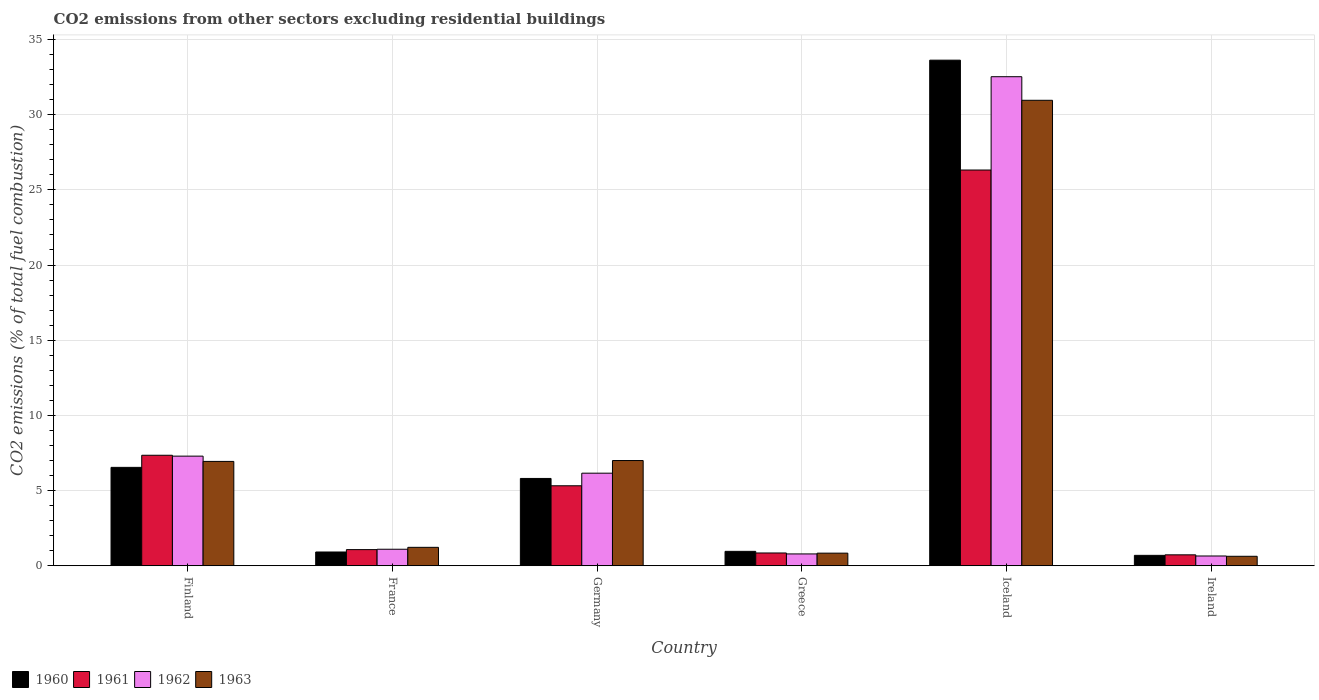How many different coloured bars are there?
Your answer should be compact. 4. Are the number of bars per tick equal to the number of legend labels?
Give a very brief answer. Yes. How many bars are there on the 5th tick from the right?
Provide a short and direct response. 4. In how many cases, is the number of bars for a given country not equal to the number of legend labels?
Keep it short and to the point. 0. What is the total CO2 emitted in 1963 in Iceland?
Provide a succinct answer. 30.95. Across all countries, what is the maximum total CO2 emitted in 1961?
Provide a succinct answer. 26.32. Across all countries, what is the minimum total CO2 emitted in 1961?
Provide a succinct answer. 0.73. In which country was the total CO2 emitted in 1962 minimum?
Keep it short and to the point. Ireland. What is the total total CO2 emitted in 1960 in the graph?
Ensure brevity in your answer.  48.55. What is the difference between the total CO2 emitted in 1961 in Greece and that in Ireland?
Provide a succinct answer. 0.12. What is the difference between the total CO2 emitted in 1963 in Ireland and the total CO2 emitted in 1960 in Germany?
Offer a terse response. -5.18. What is the average total CO2 emitted in 1960 per country?
Your answer should be compact. 8.09. What is the difference between the total CO2 emitted of/in 1960 and total CO2 emitted of/in 1962 in Greece?
Your response must be concise. 0.17. In how many countries, is the total CO2 emitted in 1960 greater than 30?
Your answer should be compact. 1. What is the ratio of the total CO2 emitted in 1960 in Greece to that in Ireland?
Provide a succinct answer. 1.38. What is the difference between the highest and the second highest total CO2 emitted in 1963?
Your answer should be very brief. -24.01. What is the difference between the highest and the lowest total CO2 emitted in 1961?
Your answer should be very brief. 25.59. Is the sum of the total CO2 emitted in 1962 in France and Ireland greater than the maximum total CO2 emitted in 1963 across all countries?
Give a very brief answer. No. Is it the case that in every country, the sum of the total CO2 emitted in 1962 and total CO2 emitted in 1960 is greater than the sum of total CO2 emitted in 1961 and total CO2 emitted in 1963?
Keep it short and to the point. No. What does the 1st bar from the left in Ireland represents?
Keep it short and to the point. 1960. What does the 1st bar from the right in Greece represents?
Provide a short and direct response. 1963. Is it the case that in every country, the sum of the total CO2 emitted in 1960 and total CO2 emitted in 1962 is greater than the total CO2 emitted in 1961?
Ensure brevity in your answer.  Yes. How many bars are there?
Ensure brevity in your answer.  24. How many countries are there in the graph?
Offer a very short reply. 6. Are the values on the major ticks of Y-axis written in scientific E-notation?
Your answer should be compact. No. Does the graph contain any zero values?
Provide a succinct answer. No. Does the graph contain grids?
Your answer should be compact. Yes. Where does the legend appear in the graph?
Give a very brief answer. Bottom left. What is the title of the graph?
Keep it short and to the point. CO2 emissions from other sectors excluding residential buildings. What is the label or title of the X-axis?
Give a very brief answer. Country. What is the label or title of the Y-axis?
Offer a terse response. CO2 emissions (% of total fuel combustion). What is the CO2 emissions (% of total fuel combustion) of 1960 in Finland?
Make the answer very short. 6.54. What is the CO2 emissions (% of total fuel combustion) of 1961 in Finland?
Provide a succinct answer. 7.35. What is the CO2 emissions (% of total fuel combustion) of 1962 in Finland?
Offer a terse response. 7.29. What is the CO2 emissions (% of total fuel combustion) in 1963 in Finland?
Your answer should be very brief. 6.94. What is the CO2 emissions (% of total fuel combustion) of 1960 in France?
Your response must be concise. 0.92. What is the CO2 emissions (% of total fuel combustion) of 1961 in France?
Make the answer very short. 1.08. What is the CO2 emissions (% of total fuel combustion) of 1962 in France?
Ensure brevity in your answer.  1.1. What is the CO2 emissions (% of total fuel combustion) of 1963 in France?
Offer a very short reply. 1.23. What is the CO2 emissions (% of total fuel combustion) of 1960 in Germany?
Your answer should be compact. 5.81. What is the CO2 emissions (% of total fuel combustion) in 1961 in Germany?
Offer a terse response. 5.32. What is the CO2 emissions (% of total fuel combustion) of 1962 in Germany?
Your response must be concise. 6.16. What is the CO2 emissions (% of total fuel combustion) in 1963 in Germany?
Offer a very short reply. 7. What is the CO2 emissions (% of total fuel combustion) in 1960 in Greece?
Your answer should be very brief. 0.96. What is the CO2 emissions (% of total fuel combustion) of 1961 in Greece?
Offer a very short reply. 0.85. What is the CO2 emissions (% of total fuel combustion) of 1962 in Greece?
Keep it short and to the point. 0.79. What is the CO2 emissions (% of total fuel combustion) of 1963 in Greece?
Ensure brevity in your answer.  0.84. What is the CO2 emissions (% of total fuel combustion) of 1960 in Iceland?
Ensure brevity in your answer.  33.62. What is the CO2 emissions (% of total fuel combustion) of 1961 in Iceland?
Your response must be concise. 26.32. What is the CO2 emissions (% of total fuel combustion) in 1962 in Iceland?
Your response must be concise. 32.52. What is the CO2 emissions (% of total fuel combustion) in 1963 in Iceland?
Make the answer very short. 30.95. What is the CO2 emissions (% of total fuel combustion) in 1960 in Ireland?
Make the answer very short. 0.69. What is the CO2 emissions (% of total fuel combustion) in 1961 in Ireland?
Provide a succinct answer. 0.73. What is the CO2 emissions (% of total fuel combustion) of 1962 in Ireland?
Ensure brevity in your answer.  0.65. What is the CO2 emissions (% of total fuel combustion) of 1963 in Ireland?
Give a very brief answer. 0.63. Across all countries, what is the maximum CO2 emissions (% of total fuel combustion) of 1960?
Your answer should be very brief. 33.62. Across all countries, what is the maximum CO2 emissions (% of total fuel combustion) of 1961?
Provide a succinct answer. 26.32. Across all countries, what is the maximum CO2 emissions (% of total fuel combustion) in 1962?
Ensure brevity in your answer.  32.52. Across all countries, what is the maximum CO2 emissions (% of total fuel combustion) in 1963?
Your answer should be very brief. 30.95. Across all countries, what is the minimum CO2 emissions (% of total fuel combustion) in 1960?
Your answer should be compact. 0.69. Across all countries, what is the minimum CO2 emissions (% of total fuel combustion) of 1961?
Provide a succinct answer. 0.73. Across all countries, what is the minimum CO2 emissions (% of total fuel combustion) of 1962?
Give a very brief answer. 0.65. Across all countries, what is the minimum CO2 emissions (% of total fuel combustion) in 1963?
Your answer should be very brief. 0.63. What is the total CO2 emissions (% of total fuel combustion) in 1960 in the graph?
Offer a very short reply. 48.55. What is the total CO2 emissions (% of total fuel combustion) in 1961 in the graph?
Keep it short and to the point. 41.64. What is the total CO2 emissions (% of total fuel combustion) of 1962 in the graph?
Your answer should be very brief. 48.51. What is the total CO2 emissions (% of total fuel combustion) in 1963 in the graph?
Make the answer very short. 47.59. What is the difference between the CO2 emissions (% of total fuel combustion) of 1960 in Finland and that in France?
Make the answer very short. 5.63. What is the difference between the CO2 emissions (% of total fuel combustion) in 1961 in Finland and that in France?
Your response must be concise. 6.27. What is the difference between the CO2 emissions (% of total fuel combustion) in 1962 in Finland and that in France?
Your answer should be very brief. 6.19. What is the difference between the CO2 emissions (% of total fuel combustion) in 1963 in Finland and that in France?
Offer a terse response. 5.71. What is the difference between the CO2 emissions (% of total fuel combustion) in 1960 in Finland and that in Germany?
Provide a short and direct response. 0.74. What is the difference between the CO2 emissions (% of total fuel combustion) of 1961 in Finland and that in Germany?
Your answer should be compact. 2.03. What is the difference between the CO2 emissions (% of total fuel combustion) of 1962 in Finland and that in Germany?
Provide a succinct answer. 1.13. What is the difference between the CO2 emissions (% of total fuel combustion) in 1963 in Finland and that in Germany?
Ensure brevity in your answer.  -0.06. What is the difference between the CO2 emissions (% of total fuel combustion) in 1960 in Finland and that in Greece?
Offer a very short reply. 5.58. What is the difference between the CO2 emissions (% of total fuel combustion) of 1961 in Finland and that in Greece?
Provide a short and direct response. 6.5. What is the difference between the CO2 emissions (% of total fuel combustion) of 1962 in Finland and that in Greece?
Your answer should be very brief. 6.5. What is the difference between the CO2 emissions (% of total fuel combustion) in 1963 in Finland and that in Greece?
Provide a succinct answer. 6.1. What is the difference between the CO2 emissions (% of total fuel combustion) of 1960 in Finland and that in Iceland?
Provide a succinct answer. -27.08. What is the difference between the CO2 emissions (% of total fuel combustion) of 1961 in Finland and that in Iceland?
Provide a succinct answer. -18.97. What is the difference between the CO2 emissions (% of total fuel combustion) in 1962 in Finland and that in Iceland?
Offer a terse response. -25.23. What is the difference between the CO2 emissions (% of total fuel combustion) in 1963 in Finland and that in Iceland?
Offer a terse response. -24.01. What is the difference between the CO2 emissions (% of total fuel combustion) in 1960 in Finland and that in Ireland?
Give a very brief answer. 5.85. What is the difference between the CO2 emissions (% of total fuel combustion) in 1961 in Finland and that in Ireland?
Ensure brevity in your answer.  6.62. What is the difference between the CO2 emissions (% of total fuel combustion) in 1962 in Finland and that in Ireland?
Your answer should be very brief. 6.64. What is the difference between the CO2 emissions (% of total fuel combustion) of 1963 in Finland and that in Ireland?
Offer a very short reply. 6.31. What is the difference between the CO2 emissions (% of total fuel combustion) in 1960 in France and that in Germany?
Provide a short and direct response. -4.89. What is the difference between the CO2 emissions (% of total fuel combustion) in 1961 in France and that in Germany?
Your answer should be compact. -4.25. What is the difference between the CO2 emissions (% of total fuel combustion) of 1962 in France and that in Germany?
Your response must be concise. -5.06. What is the difference between the CO2 emissions (% of total fuel combustion) of 1963 in France and that in Germany?
Offer a terse response. -5.77. What is the difference between the CO2 emissions (% of total fuel combustion) in 1960 in France and that in Greece?
Keep it short and to the point. -0.04. What is the difference between the CO2 emissions (% of total fuel combustion) in 1961 in France and that in Greece?
Make the answer very short. 0.22. What is the difference between the CO2 emissions (% of total fuel combustion) in 1962 in France and that in Greece?
Provide a short and direct response. 0.31. What is the difference between the CO2 emissions (% of total fuel combustion) in 1963 in France and that in Greece?
Provide a short and direct response. 0.39. What is the difference between the CO2 emissions (% of total fuel combustion) in 1960 in France and that in Iceland?
Offer a terse response. -32.7. What is the difference between the CO2 emissions (% of total fuel combustion) of 1961 in France and that in Iceland?
Provide a short and direct response. -25.24. What is the difference between the CO2 emissions (% of total fuel combustion) in 1962 in France and that in Iceland?
Provide a short and direct response. -31.42. What is the difference between the CO2 emissions (% of total fuel combustion) of 1963 in France and that in Iceland?
Keep it short and to the point. -29.73. What is the difference between the CO2 emissions (% of total fuel combustion) of 1960 in France and that in Ireland?
Offer a very short reply. 0.22. What is the difference between the CO2 emissions (% of total fuel combustion) in 1961 in France and that in Ireland?
Your answer should be compact. 0.35. What is the difference between the CO2 emissions (% of total fuel combustion) of 1962 in France and that in Ireland?
Keep it short and to the point. 0.45. What is the difference between the CO2 emissions (% of total fuel combustion) in 1963 in France and that in Ireland?
Offer a very short reply. 0.59. What is the difference between the CO2 emissions (% of total fuel combustion) in 1960 in Germany and that in Greece?
Make the answer very short. 4.85. What is the difference between the CO2 emissions (% of total fuel combustion) of 1961 in Germany and that in Greece?
Keep it short and to the point. 4.47. What is the difference between the CO2 emissions (% of total fuel combustion) in 1962 in Germany and that in Greece?
Provide a succinct answer. 5.37. What is the difference between the CO2 emissions (% of total fuel combustion) of 1963 in Germany and that in Greece?
Give a very brief answer. 6.16. What is the difference between the CO2 emissions (% of total fuel combustion) of 1960 in Germany and that in Iceland?
Your answer should be very brief. -27.81. What is the difference between the CO2 emissions (% of total fuel combustion) of 1961 in Germany and that in Iceland?
Ensure brevity in your answer.  -20.99. What is the difference between the CO2 emissions (% of total fuel combustion) in 1962 in Germany and that in Iceland?
Make the answer very short. -26.36. What is the difference between the CO2 emissions (% of total fuel combustion) of 1963 in Germany and that in Iceland?
Your answer should be very brief. -23.95. What is the difference between the CO2 emissions (% of total fuel combustion) in 1960 in Germany and that in Ireland?
Provide a succinct answer. 5.11. What is the difference between the CO2 emissions (% of total fuel combustion) of 1961 in Germany and that in Ireland?
Ensure brevity in your answer.  4.59. What is the difference between the CO2 emissions (% of total fuel combustion) in 1962 in Germany and that in Ireland?
Ensure brevity in your answer.  5.51. What is the difference between the CO2 emissions (% of total fuel combustion) of 1963 in Germany and that in Ireland?
Keep it short and to the point. 6.37. What is the difference between the CO2 emissions (% of total fuel combustion) of 1960 in Greece and that in Iceland?
Your answer should be very brief. -32.66. What is the difference between the CO2 emissions (% of total fuel combustion) of 1961 in Greece and that in Iceland?
Your answer should be compact. -25.46. What is the difference between the CO2 emissions (% of total fuel combustion) of 1962 in Greece and that in Iceland?
Offer a terse response. -31.73. What is the difference between the CO2 emissions (% of total fuel combustion) in 1963 in Greece and that in Iceland?
Keep it short and to the point. -30.11. What is the difference between the CO2 emissions (% of total fuel combustion) in 1960 in Greece and that in Ireland?
Provide a short and direct response. 0.27. What is the difference between the CO2 emissions (% of total fuel combustion) in 1961 in Greece and that in Ireland?
Your response must be concise. 0.12. What is the difference between the CO2 emissions (% of total fuel combustion) in 1962 in Greece and that in Ireland?
Keep it short and to the point. 0.14. What is the difference between the CO2 emissions (% of total fuel combustion) in 1963 in Greece and that in Ireland?
Offer a terse response. 0.21. What is the difference between the CO2 emissions (% of total fuel combustion) of 1960 in Iceland and that in Ireland?
Your answer should be very brief. 32.93. What is the difference between the CO2 emissions (% of total fuel combustion) of 1961 in Iceland and that in Ireland?
Give a very brief answer. 25.59. What is the difference between the CO2 emissions (% of total fuel combustion) in 1962 in Iceland and that in Ireland?
Give a very brief answer. 31.87. What is the difference between the CO2 emissions (% of total fuel combustion) of 1963 in Iceland and that in Ireland?
Provide a succinct answer. 30.32. What is the difference between the CO2 emissions (% of total fuel combustion) in 1960 in Finland and the CO2 emissions (% of total fuel combustion) in 1961 in France?
Provide a succinct answer. 5.47. What is the difference between the CO2 emissions (% of total fuel combustion) in 1960 in Finland and the CO2 emissions (% of total fuel combustion) in 1962 in France?
Ensure brevity in your answer.  5.44. What is the difference between the CO2 emissions (% of total fuel combustion) of 1960 in Finland and the CO2 emissions (% of total fuel combustion) of 1963 in France?
Make the answer very short. 5.32. What is the difference between the CO2 emissions (% of total fuel combustion) in 1961 in Finland and the CO2 emissions (% of total fuel combustion) in 1962 in France?
Provide a short and direct response. 6.25. What is the difference between the CO2 emissions (% of total fuel combustion) in 1961 in Finland and the CO2 emissions (% of total fuel combustion) in 1963 in France?
Make the answer very short. 6.12. What is the difference between the CO2 emissions (% of total fuel combustion) of 1962 in Finland and the CO2 emissions (% of total fuel combustion) of 1963 in France?
Provide a short and direct response. 6.06. What is the difference between the CO2 emissions (% of total fuel combustion) in 1960 in Finland and the CO2 emissions (% of total fuel combustion) in 1961 in Germany?
Your response must be concise. 1.22. What is the difference between the CO2 emissions (% of total fuel combustion) of 1960 in Finland and the CO2 emissions (% of total fuel combustion) of 1962 in Germany?
Provide a short and direct response. 0.39. What is the difference between the CO2 emissions (% of total fuel combustion) of 1960 in Finland and the CO2 emissions (% of total fuel combustion) of 1963 in Germany?
Offer a very short reply. -0.45. What is the difference between the CO2 emissions (% of total fuel combustion) of 1961 in Finland and the CO2 emissions (% of total fuel combustion) of 1962 in Germany?
Provide a short and direct response. 1.19. What is the difference between the CO2 emissions (% of total fuel combustion) of 1961 in Finland and the CO2 emissions (% of total fuel combustion) of 1963 in Germany?
Provide a short and direct response. 0.35. What is the difference between the CO2 emissions (% of total fuel combustion) of 1962 in Finland and the CO2 emissions (% of total fuel combustion) of 1963 in Germany?
Give a very brief answer. 0.29. What is the difference between the CO2 emissions (% of total fuel combustion) in 1960 in Finland and the CO2 emissions (% of total fuel combustion) in 1961 in Greece?
Ensure brevity in your answer.  5.69. What is the difference between the CO2 emissions (% of total fuel combustion) of 1960 in Finland and the CO2 emissions (% of total fuel combustion) of 1962 in Greece?
Offer a very short reply. 5.76. What is the difference between the CO2 emissions (% of total fuel combustion) of 1960 in Finland and the CO2 emissions (% of total fuel combustion) of 1963 in Greece?
Offer a terse response. 5.7. What is the difference between the CO2 emissions (% of total fuel combustion) in 1961 in Finland and the CO2 emissions (% of total fuel combustion) in 1962 in Greece?
Offer a very short reply. 6.56. What is the difference between the CO2 emissions (% of total fuel combustion) of 1961 in Finland and the CO2 emissions (% of total fuel combustion) of 1963 in Greece?
Give a very brief answer. 6.51. What is the difference between the CO2 emissions (% of total fuel combustion) of 1962 in Finland and the CO2 emissions (% of total fuel combustion) of 1963 in Greece?
Provide a short and direct response. 6.45. What is the difference between the CO2 emissions (% of total fuel combustion) of 1960 in Finland and the CO2 emissions (% of total fuel combustion) of 1961 in Iceland?
Your answer should be very brief. -19.77. What is the difference between the CO2 emissions (% of total fuel combustion) in 1960 in Finland and the CO2 emissions (% of total fuel combustion) in 1962 in Iceland?
Ensure brevity in your answer.  -25.98. What is the difference between the CO2 emissions (% of total fuel combustion) of 1960 in Finland and the CO2 emissions (% of total fuel combustion) of 1963 in Iceland?
Make the answer very short. -24.41. What is the difference between the CO2 emissions (% of total fuel combustion) in 1961 in Finland and the CO2 emissions (% of total fuel combustion) in 1962 in Iceland?
Your answer should be very brief. -25.17. What is the difference between the CO2 emissions (% of total fuel combustion) of 1961 in Finland and the CO2 emissions (% of total fuel combustion) of 1963 in Iceland?
Provide a short and direct response. -23.6. What is the difference between the CO2 emissions (% of total fuel combustion) of 1962 in Finland and the CO2 emissions (% of total fuel combustion) of 1963 in Iceland?
Provide a short and direct response. -23.66. What is the difference between the CO2 emissions (% of total fuel combustion) of 1960 in Finland and the CO2 emissions (% of total fuel combustion) of 1961 in Ireland?
Keep it short and to the point. 5.82. What is the difference between the CO2 emissions (% of total fuel combustion) of 1960 in Finland and the CO2 emissions (% of total fuel combustion) of 1962 in Ireland?
Your response must be concise. 5.89. What is the difference between the CO2 emissions (% of total fuel combustion) of 1960 in Finland and the CO2 emissions (% of total fuel combustion) of 1963 in Ireland?
Give a very brief answer. 5.91. What is the difference between the CO2 emissions (% of total fuel combustion) in 1961 in Finland and the CO2 emissions (% of total fuel combustion) in 1962 in Ireland?
Offer a very short reply. 6.7. What is the difference between the CO2 emissions (% of total fuel combustion) of 1961 in Finland and the CO2 emissions (% of total fuel combustion) of 1963 in Ireland?
Your answer should be compact. 6.72. What is the difference between the CO2 emissions (% of total fuel combustion) of 1962 in Finland and the CO2 emissions (% of total fuel combustion) of 1963 in Ireland?
Provide a short and direct response. 6.66. What is the difference between the CO2 emissions (% of total fuel combustion) of 1960 in France and the CO2 emissions (% of total fuel combustion) of 1961 in Germany?
Offer a terse response. -4.4. What is the difference between the CO2 emissions (% of total fuel combustion) in 1960 in France and the CO2 emissions (% of total fuel combustion) in 1962 in Germany?
Ensure brevity in your answer.  -5.24. What is the difference between the CO2 emissions (% of total fuel combustion) of 1960 in France and the CO2 emissions (% of total fuel combustion) of 1963 in Germany?
Provide a succinct answer. -6.08. What is the difference between the CO2 emissions (% of total fuel combustion) of 1961 in France and the CO2 emissions (% of total fuel combustion) of 1962 in Germany?
Your answer should be very brief. -5.08. What is the difference between the CO2 emissions (% of total fuel combustion) of 1961 in France and the CO2 emissions (% of total fuel combustion) of 1963 in Germany?
Provide a succinct answer. -5.92. What is the difference between the CO2 emissions (% of total fuel combustion) in 1962 in France and the CO2 emissions (% of total fuel combustion) in 1963 in Germany?
Your answer should be very brief. -5.9. What is the difference between the CO2 emissions (% of total fuel combustion) of 1960 in France and the CO2 emissions (% of total fuel combustion) of 1961 in Greece?
Provide a short and direct response. 0.06. What is the difference between the CO2 emissions (% of total fuel combustion) in 1960 in France and the CO2 emissions (% of total fuel combustion) in 1962 in Greece?
Make the answer very short. 0.13. What is the difference between the CO2 emissions (% of total fuel combustion) of 1960 in France and the CO2 emissions (% of total fuel combustion) of 1963 in Greece?
Make the answer very short. 0.08. What is the difference between the CO2 emissions (% of total fuel combustion) in 1961 in France and the CO2 emissions (% of total fuel combustion) in 1962 in Greece?
Provide a short and direct response. 0.29. What is the difference between the CO2 emissions (% of total fuel combustion) of 1961 in France and the CO2 emissions (% of total fuel combustion) of 1963 in Greece?
Provide a short and direct response. 0.23. What is the difference between the CO2 emissions (% of total fuel combustion) in 1962 in France and the CO2 emissions (% of total fuel combustion) in 1963 in Greece?
Make the answer very short. 0.26. What is the difference between the CO2 emissions (% of total fuel combustion) of 1960 in France and the CO2 emissions (% of total fuel combustion) of 1961 in Iceland?
Your response must be concise. -25.4. What is the difference between the CO2 emissions (% of total fuel combustion) of 1960 in France and the CO2 emissions (% of total fuel combustion) of 1962 in Iceland?
Offer a very short reply. -31.6. What is the difference between the CO2 emissions (% of total fuel combustion) in 1960 in France and the CO2 emissions (% of total fuel combustion) in 1963 in Iceland?
Your response must be concise. -30.04. What is the difference between the CO2 emissions (% of total fuel combustion) of 1961 in France and the CO2 emissions (% of total fuel combustion) of 1962 in Iceland?
Ensure brevity in your answer.  -31.44. What is the difference between the CO2 emissions (% of total fuel combustion) in 1961 in France and the CO2 emissions (% of total fuel combustion) in 1963 in Iceland?
Make the answer very short. -29.88. What is the difference between the CO2 emissions (% of total fuel combustion) of 1962 in France and the CO2 emissions (% of total fuel combustion) of 1963 in Iceland?
Offer a terse response. -29.85. What is the difference between the CO2 emissions (% of total fuel combustion) in 1960 in France and the CO2 emissions (% of total fuel combustion) in 1961 in Ireland?
Keep it short and to the point. 0.19. What is the difference between the CO2 emissions (% of total fuel combustion) of 1960 in France and the CO2 emissions (% of total fuel combustion) of 1962 in Ireland?
Keep it short and to the point. 0.27. What is the difference between the CO2 emissions (% of total fuel combustion) of 1960 in France and the CO2 emissions (% of total fuel combustion) of 1963 in Ireland?
Keep it short and to the point. 0.29. What is the difference between the CO2 emissions (% of total fuel combustion) of 1961 in France and the CO2 emissions (% of total fuel combustion) of 1962 in Ireland?
Offer a terse response. 0.42. What is the difference between the CO2 emissions (% of total fuel combustion) of 1961 in France and the CO2 emissions (% of total fuel combustion) of 1963 in Ireland?
Your answer should be very brief. 0.44. What is the difference between the CO2 emissions (% of total fuel combustion) in 1962 in France and the CO2 emissions (% of total fuel combustion) in 1963 in Ireland?
Provide a succinct answer. 0.47. What is the difference between the CO2 emissions (% of total fuel combustion) in 1960 in Germany and the CO2 emissions (% of total fuel combustion) in 1961 in Greece?
Ensure brevity in your answer.  4.96. What is the difference between the CO2 emissions (% of total fuel combustion) of 1960 in Germany and the CO2 emissions (% of total fuel combustion) of 1962 in Greece?
Make the answer very short. 5.02. What is the difference between the CO2 emissions (% of total fuel combustion) of 1960 in Germany and the CO2 emissions (% of total fuel combustion) of 1963 in Greece?
Your answer should be very brief. 4.97. What is the difference between the CO2 emissions (% of total fuel combustion) of 1961 in Germany and the CO2 emissions (% of total fuel combustion) of 1962 in Greece?
Offer a very short reply. 4.53. What is the difference between the CO2 emissions (% of total fuel combustion) of 1961 in Germany and the CO2 emissions (% of total fuel combustion) of 1963 in Greece?
Provide a succinct answer. 4.48. What is the difference between the CO2 emissions (% of total fuel combustion) of 1962 in Germany and the CO2 emissions (% of total fuel combustion) of 1963 in Greece?
Provide a succinct answer. 5.32. What is the difference between the CO2 emissions (% of total fuel combustion) of 1960 in Germany and the CO2 emissions (% of total fuel combustion) of 1961 in Iceland?
Offer a terse response. -20.51. What is the difference between the CO2 emissions (% of total fuel combustion) in 1960 in Germany and the CO2 emissions (% of total fuel combustion) in 1962 in Iceland?
Your answer should be compact. -26.71. What is the difference between the CO2 emissions (% of total fuel combustion) in 1960 in Germany and the CO2 emissions (% of total fuel combustion) in 1963 in Iceland?
Your answer should be compact. -25.14. What is the difference between the CO2 emissions (% of total fuel combustion) of 1961 in Germany and the CO2 emissions (% of total fuel combustion) of 1962 in Iceland?
Provide a succinct answer. -27.2. What is the difference between the CO2 emissions (% of total fuel combustion) in 1961 in Germany and the CO2 emissions (% of total fuel combustion) in 1963 in Iceland?
Offer a terse response. -25.63. What is the difference between the CO2 emissions (% of total fuel combustion) of 1962 in Germany and the CO2 emissions (% of total fuel combustion) of 1963 in Iceland?
Provide a succinct answer. -24.79. What is the difference between the CO2 emissions (% of total fuel combustion) of 1960 in Germany and the CO2 emissions (% of total fuel combustion) of 1961 in Ireland?
Your answer should be very brief. 5.08. What is the difference between the CO2 emissions (% of total fuel combustion) in 1960 in Germany and the CO2 emissions (% of total fuel combustion) in 1962 in Ireland?
Your answer should be compact. 5.16. What is the difference between the CO2 emissions (% of total fuel combustion) in 1960 in Germany and the CO2 emissions (% of total fuel combustion) in 1963 in Ireland?
Offer a very short reply. 5.18. What is the difference between the CO2 emissions (% of total fuel combustion) in 1961 in Germany and the CO2 emissions (% of total fuel combustion) in 1962 in Ireland?
Your answer should be very brief. 4.67. What is the difference between the CO2 emissions (% of total fuel combustion) in 1961 in Germany and the CO2 emissions (% of total fuel combustion) in 1963 in Ireland?
Your response must be concise. 4.69. What is the difference between the CO2 emissions (% of total fuel combustion) in 1962 in Germany and the CO2 emissions (% of total fuel combustion) in 1963 in Ireland?
Provide a succinct answer. 5.53. What is the difference between the CO2 emissions (% of total fuel combustion) in 1960 in Greece and the CO2 emissions (% of total fuel combustion) in 1961 in Iceland?
Provide a succinct answer. -25.36. What is the difference between the CO2 emissions (% of total fuel combustion) of 1960 in Greece and the CO2 emissions (% of total fuel combustion) of 1962 in Iceland?
Your response must be concise. -31.56. What is the difference between the CO2 emissions (% of total fuel combustion) of 1960 in Greece and the CO2 emissions (% of total fuel combustion) of 1963 in Iceland?
Ensure brevity in your answer.  -29.99. What is the difference between the CO2 emissions (% of total fuel combustion) in 1961 in Greece and the CO2 emissions (% of total fuel combustion) in 1962 in Iceland?
Provide a succinct answer. -31.67. What is the difference between the CO2 emissions (% of total fuel combustion) of 1961 in Greece and the CO2 emissions (% of total fuel combustion) of 1963 in Iceland?
Keep it short and to the point. -30.1. What is the difference between the CO2 emissions (% of total fuel combustion) in 1962 in Greece and the CO2 emissions (% of total fuel combustion) in 1963 in Iceland?
Your answer should be compact. -30.16. What is the difference between the CO2 emissions (% of total fuel combustion) in 1960 in Greece and the CO2 emissions (% of total fuel combustion) in 1961 in Ireland?
Provide a short and direct response. 0.23. What is the difference between the CO2 emissions (% of total fuel combustion) in 1960 in Greece and the CO2 emissions (% of total fuel combustion) in 1962 in Ireland?
Provide a succinct answer. 0.31. What is the difference between the CO2 emissions (% of total fuel combustion) in 1960 in Greece and the CO2 emissions (% of total fuel combustion) in 1963 in Ireland?
Keep it short and to the point. 0.33. What is the difference between the CO2 emissions (% of total fuel combustion) of 1961 in Greece and the CO2 emissions (% of total fuel combustion) of 1962 in Ireland?
Your answer should be compact. 0.2. What is the difference between the CO2 emissions (% of total fuel combustion) of 1961 in Greece and the CO2 emissions (% of total fuel combustion) of 1963 in Ireland?
Ensure brevity in your answer.  0.22. What is the difference between the CO2 emissions (% of total fuel combustion) in 1962 in Greece and the CO2 emissions (% of total fuel combustion) in 1963 in Ireland?
Make the answer very short. 0.16. What is the difference between the CO2 emissions (% of total fuel combustion) in 1960 in Iceland and the CO2 emissions (% of total fuel combustion) in 1961 in Ireland?
Keep it short and to the point. 32.89. What is the difference between the CO2 emissions (% of total fuel combustion) of 1960 in Iceland and the CO2 emissions (% of total fuel combustion) of 1962 in Ireland?
Your answer should be compact. 32.97. What is the difference between the CO2 emissions (% of total fuel combustion) of 1960 in Iceland and the CO2 emissions (% of total fuel combustion) of 1963 in Ireland?
Provide a short and direct response. 32.99. What is the difference between the CO2 emissions (% of total fuel combustion) in 1961 in Iceland and the CO2 emissions (% of total fuel combustion) in 1962 in Ireland?
Your answer should be compact. 25.66. What is the difference between the CO2 emissions (% of total fuel combustion) of 1961 in Iceland and the CO2 emissions (% of total fuel combustion) of 1963 in Ireland?
Your response must be concise. 25.68. What is the difference between the CO2 emissions (% of total fuel combustion) in 1962 in Iceland and the CO2 emissions (% of total fuel combustion) in 1963 in Ireland?
Make the answer very short. 31.89. What is the average CO2 emissions (% of total fuel combustion) of 1960 per country?
Your answer should be compact. 8.09. What is the average CO2 emissions (% of total fuel combustion) of 1961 per country?
Ensure brevity in your answer.  6.94. What is the average CO2 emissions (% of total fuel combustion) of 1962 per country?
Your response must be concise. 8.09. What is the average CO2 emissions (% of total fuel combustion) in 1963 per country?
Offer a terse response. 7.93. What is the difference between the CO2 emissions (% of total fuel combustion) in 1960 and CO2 emissions (% of total fuel combustion) in 1961 in Finland?
Your answer should be very brief. -0.81. What is the difference between the CO2 emissions (% of total fuel combustion) of 1960 and CO2 emissions (% of total fuel combustion) of 1962 in Finland?
Your response must be concise. -0.75. What is the difference between the CO2 emissions (% of total fuel combustion) of 1960 and CO2 emissions (% of total fuel combustion) of 1963 in Finland?
Provide a succinct answer. -0.4. What is the difference between the CO2 emissions (% of total fuel combustion) of 1961 and CO2 emissions (% of total fuel combustion) of 1962 in Finland?
Your response must be concise. 0.06. What is the difference between the CO2 emissions (% of total fuel combustion) of 1961 and CO2 emissions (% of total fuel combustion) of 1963 in Finland?
Offer a terse response. 0.41. What is the difference between the CO2 emissions (% of total fuel combustion) in 1962 and CO2 emissions (% of total fuel combustion) in 1963 in Finland?
Make the answer very short. 0.35. What is the difference between the CO2 emissions (% of total fuel combustion) in 1960 and CO2 emissions (% of total fuel combustion) in 1961 in France?
Your answer should be very brief. -0.16. What is the difference between the CO2 emissions (% of total fuel combustion) in 1960 and CO2 emissions (% of total fuel combustion) in 1962 in France?
Your answer should be compact. -0.18. What is the difference between the CO2 emissions (% of total fuel combustion) of 1960 and CO2 emissions (% of total fuel combustion) of 1963 in France?
Make the answer very short. -0.31. What is the difference between the CO2 emissions (% of total fuel combustion) in 1961 and CO2 emissions (% of total fuel combustion) in 1962 in France?
Your response must be concise. -0.02. What is the difference between the CO2 emissions (% of total fuel combustion) in 1961 and CO2 emissions (% of total fuel combustion) in 1963 in France?
Make the answer very short. -0.15. What is the difference between the CO2 emissions (% of total fuel combustion) in 1962 and CO2 emissions (% of total fuel combustion) in 1963 in France?
Your response must be concise. -0.13. What is the difference between the CO2 emissions (% of total fuel combustion) of 1960 and CO2 emissions (% of total fuel combustion) of 1961 in Germany?
Provide a short and direct response. 0.49. What is the difference between the CO2 emissions (% of total fuel combustion) of 1960 and CO2 emissions (% of total fuel combustion) of 1962 in Germany?
Your response must be concise. -0.35. What is the difference between the CO2 emissions (% of total fuel combustion) of 1960 and CO2 emissions (% of total fuel combustion) of 1963 in Germany?
Offer a terse response. -1.19. What is the difference between the CO2 emissions (% of total fuel combustion) in 1961 and CO2 emissions (% of total fuel combustion) in 1962 in Germany?
Ensure brevity in your answer.  -0.84. What is the difference between the CO2 emissions (% of total fuel combustion) in 1961 and CO2 emissions (% of total fuel combustion) in 1963 in Germany?
Keep it short and to the point. -1.68. What is the difference between the CO2 emissions (% of total fuel combustion) in 1962 and CO2 emissions (% of total fuel combustion) in 1963 in Germany?
Keep it short and to the point. -0.84. What is the difference between the CO2 emissions (% of total fuel combustion) of 1960 and CO2 emissions (% of total fuel combustion) of 1961 in Greece?
Provide a short and direct response. 0.11. What is the difference between the CO2 emissions (% of total fuel combustion) of 1960 and CO2 emissions (% of total fuel combustion) of 1962 in Greece?
Provide a succinct answer. 0.17. What is the difference between the CO2 emissions (% of total fuel combustion) in 1960 and CO2 emissions (% of total fuel combustion) in 1963 in Greece?
Offer a terse response. 0.12. What is the difference between the CO2 emissions (% of total fuel combustion) in 1961 and CO2 emissions (% of total fuel combustion) in 1962 in Greece?
Offer a terse response. 0.06. What is the difference between the CO2 emissions (% of total fuel combustion) in 1961 and CO2 emissions (% of total fuel combustion) in 1963 in Greece?
Keep it short and to the point. 0.01. What is the difference between the CO2 emissions (% of total fuel combustion) of 1962 and CO2 emissions (% of total fuel combustion) of 1963 in Greece?
Ensure brevity in your answer.  -0.05. What is the difference between the CO2 emissions (% of total fuel combustion) of 1960 and CO2 emissions (% of total fuel combustion) of 1961 in Iceland?
Offer a terse response. 7.3. What is the difference between the CO2 emissions (% of total fuel combustion) of 1960 and CO2 emissions (% of total fuel combustion) of 1962 in Iceland?
Keep it short and to the point. 1.1. What is the difference between the CO2 emissions (% of total fuel combustion) of 1960 and CO2 emissions (% of total fuel combustion) of 1963 in Iceland?
Provide a short and direct response. 2.67. What is the difference between the CO2 emissions (% of total fuel combustion) of 1961 and CO2 emissions (% of total fuel combustion) of 1962 in Iceland?
Provide a short and direct response. -6.2. What is the difference between the CO2 emissions (% of total fuel combustion) in 1961 and CO2 emissions (% of total fuel combustion) in 1963 in Iceland?
Your answer should be very brief. -4.64. What is the difference between the CO2 emissions (% of total fuel combustion) of 1962 and CO2 emissions (% of total fuel combustion) of 1963 in Iceland?
Offer a very short reply. 1.57. What is the difference between the CO2 emissions (% of total fuel combustion) of 1960 and CO2 emissions (% of total fuel combustion) of 1961 in Ireland?
Keep it short and to the point. -0.03. What is the difference between the CO2 emissions (% of total fuel combustion) in 1960 and CO2 emissions (% of total fuel combustion) in 1962 in Ireland?
Keep it short and to the point. 0.04. What is the difference between the CO2 emissions (% of total fuel combustion) of 1960 and CO2 emissions (% of total fuel combustion) of 1963 in Ireland?
Ensure brevity in your answer.  0.06. What is the difference between the CO2 emissions (% of total fuel combustion) of 1961 and CO2 emissions (% of total fuel combustion) of 1962 in Ireland?
Make the answer very short. 0.08. What is the difference between the CO2 emissions (% of total fuel combustion) of 1961 and CO2 emissions (% of total fuel combustion) of 1963 in Ireland?
Your answer should be very brief. 0.1. What is the difference between the CO2 emissions (% of total fuel combustion) of 1962 and CO2 emissions (% of total fuel combustion) of 1963 in Ireland?
Make the answer very short. 0.02. What is the ratio of the CO2 emissions (% of total fuel combustion) of 1960 in Finland to that in France?
Offer a very short reply. 7.14. What is the ratio of the CO2 emissions (% of total fuel combustion) in 1961 in Finland to that in France?
Provide a succinct answer. 6.83. What is the ratio of the CO2 emissions (% of total fuel combustion) in 1962 in Finland to that in France?
Offer a very short reply. 6.63. What is the ratio of the CO2 emissions (% of total fuel combustion) in 1963 in Finland to that in France?
Your answer should be very brief. 5.66. What is the ratio of the CO2 emissions (% of total fuel combustion) of 1960 in Finland to that in Germany?
Ensure brevity in your answer.  1.13. What is the ratio of the CO2 emissions (% of total fuel combustion) of 1961 in Finland to that in Germany?
Give a very brief answer. 1.38. What is the ratio of the CO2 emissions (% of total fuel combustion) of 1962 in Finland to that in Germany?
Keep it short and to the point. 1.18. What is the ratio of the CO2 emissions (% of total fuel combustion) in 1960 in Finland to that in Greece?
Ensure brevity in your answer.  6.82. What is the ratio of the CO2 emissions (% of total fuel combustion) of 1961 in Finland to that in Greece?
Make the answer very short. 8.62. What is the ratio of the CO2 emissions (% of total fuel combustion) of 1962 in Finland to that in Greece?
Your answer should be compact. 9.24. What is the ratio of the CO2 emissions (% of total fuel combustion) of 1963 in Finland to that in Greece?
Keep it short and to the point. 8.25. What is the ratio of the CO2 emissions (% of total fuel combustion) of 1960 in Finland to that in Iceland?
Ensure brevity in your answer.  0.19. What is the ratio of the CO2 emissions (% of total fuel combustion) of 1961 in Finland to that in Iceland?
Give a very brief answer. 0.28. What is the ratio of the CO2 emissions (% of total fuel combustion) of 1962 in Finland to that in Iceland?
Provide a short and direct response. 0.22. What is the ratio of the CO2 emissions (% of total fuel combustion) in 1963 in Finland to that in Iceland?
Keep it short and to the point. 0.22. What is the ratio of the CO2 emissions (% of total fuel combustion) of 1960 in Finland to that in Ireland?
Offer a very short reply. 9.42. What is the ratio of the CO2 emissions (% of total fuel combustion) of 1961 in Finland to that in Ireland?
Offer a terse response. 10.08. What is the ratio of the CO2 emissions (% of total fuel combustion) in 1962 in Finland to that in Ireland?
Ensure brevity in your answer.  11.2. What is the ratio of the CO2 emissions (% of total fuel combustion) in 1963 in Finland to that in Ireland?
Provide a succinct answer. 10.98. What is the ratio of the CO2 emissions (% of total fuel combustion) in 1960 in France to that in Germany?
Offer a terse response. 0.16. What is the ratio of the CO2 emissions (% of total fuel combustion) in 1961 in France to that in Germany?
Your answer should be very brief. 0.2. What is the ratio of the CO2 emissions (% of total fuel combustion) of 1962 in France to that in Germany?
Provide a succinct answer. 0.18. What is the ratio of the CO2 emissions (% of total fuel combustion) of 1963 in France to that in Germany?
Provide a short and direct response. 0.18. What is the ratio of the CO2 emissions (% of total fuel combustion) of 1960 in France to that in Greece?
Your answer should be very brief. 0.96. What is the ratio of the CO2 emissions (% of total fuel combustion) in 1961 in France to that in Greece?
Your answer should be very brief. 1.26. What is the ratio of the CO2 emissions (% of total fuel combustion) of 1962 in France to that in Greece?
Your answer should be compact. 1.39. What is the ratio of the CO2 emissions (% of total fuel combustion) of 1963 in France to that in Greece?
Your response must be concise. 1.46. What is the ratio of the CO2 emissions (% of total fuel combustion) in 1960 in France to that in Iceland?
Provide a succinct answer. 0.03. What is the ratio of the CO2 emissions (% of total fuel combustion) in 1961 in France to that in Iceland?
Offer a terse response. 0.04. What is the ratio of the CO2 emissions (% of total fuel combustion) in 1962 in France to that in Iceland?
Your response must be concise. 0.03. What is the ratio of the CO2 emissions (% of total fuel combustion) in 1963 in France to that in Iceland?
Keep it short and to the point. 0.04. What is the ratio of the CO2 emissions (% of total fuel combustion) in 1960 in France to that in Ireland?
Your answer should be very brief. 1.32. What is the ratio of the CO2 emissions (% of total fuel combustion) of 1961 in France to that in Ireland?
Offer a very short reply. 1.48. What is the ratio of the CO2 emissions (% of total fuel combustion) in 1962 in France to that in Ireland?
Offer a very short reply. 1.69. What is the ratio of the CO2 emissions (% of total fuel combustion) in 1963 in France to that in Ireland?
Your answer should be compact. 1.94. What is the ratio of the CO2 emissions (% of total fuel combustion) in 1960 in Germany to that in Greece?
Keep it short and to the point. 6.05. What is the ratio of the CO2 emissions (% of total fuel combustion) in 1961 in Germany to that in Greece?
Offer a very short reply. 6.24. What is the ratio of the CO2 emissions (% of total fuel combustion) of 1962 in Germany to that in Greece?
Keep it short and to the point. 7.8. What is the ratio of the CO2 emissions (% of total fuel combustion) of 1963 in Germany to that in Greece?
Your response must be concise. 8.32. What is the ratio of the CO2 emissions (% of total fuel combustion) of 1960 in Germany to that in Iceland?
Give a very brief answer. 0.17. What is the ratio of the CO2 emissions (% of total fuel combustion) in 1961 in Germany to that in Iceland?
Keep it short and to the point. 0.2. What is the ratio of the CO2 emissions (% of total fuel combustion) in 1962 in Germany to that in Iceland?
Your response must be concise. 0.19. What is the ratio of the CO2 emissions (% of total fuel combustion) in 1963 in Germany to that in Iceland?
Your answer should be compact. 0.23. What is the ratio of the CO2 emissions (% of total fuel combustion) in 1960 in Germany to that in Ireland?
Provide a short and direct response. 8.36. What is the ratio of the CO2 emissions (% of total fuel combustion) in 1961 in Germany to that in Ireland?
Offer a very short reply. 7.3. What is the ratio of the CO2 emissions (% of total fuel combustion) of 1962 in Germany to that in Ireland?
Provide a succinct answer. 9.46. What is the ratio of the CO2 emissions (% of total fuel combustion) in 1963 in Germany to that in Ireland?
Provide a short and direct response. 11.07. What is the ratio of the CO2 emissions (% of total fuel combustion) of 1960 in Greece to that in Iceland?
Your answer should be very brief. 0.03. What is the ratio of the CO2 emissions (% of total fuel combustion) in 1961 in Greece to that in Iceland?
Provide a short and direct response. 0.03. What is the ratio of the CO2 emissions (% of total fuel combustion) in 1962 in Greece to that in Iceland?
Offer a very short reply. 0.02. What is the ratio of the CO2 emissions (% of total fuel combustion) in 1963 in Greece to that in Iceland?
Make the answer very short. 0.03. What is the ratio of the CO2 emissions (% of total fuel combustion) of 1960 in Greece to that in Ireland?
Keep it short and to the point. 1.38. What is the ratio of the CO2 emissions (% of total fuel combustion) in 1961 in Greece to that in Ireland?
Your response must be concise. 1.17. What is the ratio of the CO2 emissions (% of total fuel combustion) in 1962 in Greece to that in Ireland?
Provide a succinct answer. 1.21. What is the ratio of the CO2 emissions (% of total fuel combustion) of 1963 in Greece to that in Ireland?
Your answer should be very brief. 1.33. What is the ratio of the CO2 emissions (% of total fuel combustion) of 1960 in Iceland to that in Ireland?
Offer a terse response. 48.41. What is the ratio of the CO2 emissions (% of total fuel combustion) of 1961 in Iceland to that in Ireland?
Provide a succinct answer. 36.11. What is the ratio of the CO2 emissions (% of total fuel combustion) in 1962 in Iceland to that in Ireland?
Offer a terse response. 49.94. What is the ratio of the CO2 emissions (% of total fuel combustion) in 1963 in Iceland to that in Ireland?
Ensure brevity in your answer.  48.97. What is the difference between the highest and the second highest CO2 emissions (% of total fuel combustion) in 1960?
Ensure brevity in your answer.  27.08. What is the difference between the highest and the second highest CO2 emissions (% of total fuel combustion) of 1961?
Provide a succinct answer. 18.97. What is the difference between the highest and the second highest CO2 emissions (% of total fuel combustion) in 1962?
Provide a succinct answer. 25.23. What is the difference between the highest and the second highest CO2 emissions (% of total fuel combustion) in 1963?
Your answer should be very brief. 23.95. What is the difference between the highest and the lowest CO2 emissions (% of total fuel combustion) in 1960?
Ensure brevity in your answer.  32.93. What is the difference between the highest and the lowest CO2 emissions (% of total fuel combustion) of 1961?
Ensure brevity in your answer.  25.59. What is the difference between the highest and the lowest CO2 emissions (% of total fuel combustion) of 1962?
Provide a short and direct response. 31.87. What is the difference between the highest and the lowest CO2 emissions (% of total fuel combustion) in 1963?
Your answer should be compact. 30.32. 